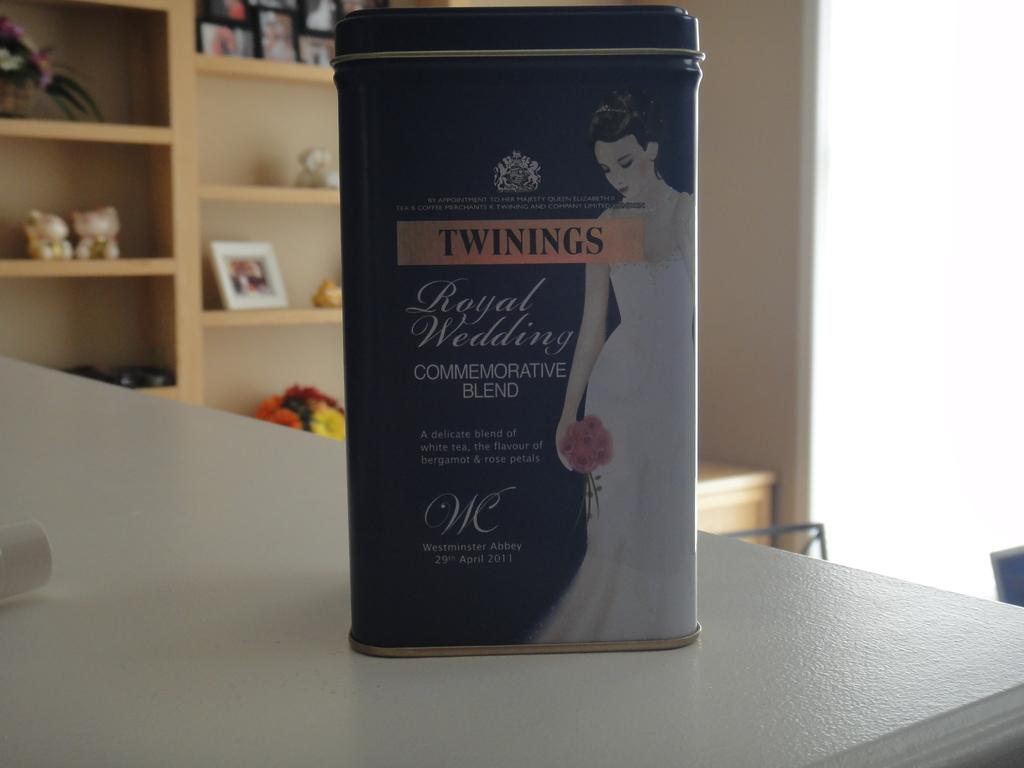<image>
Create a compact narrative representing the image presented. A box of Twinnings tea contains the royal wedding commemorative blend. 